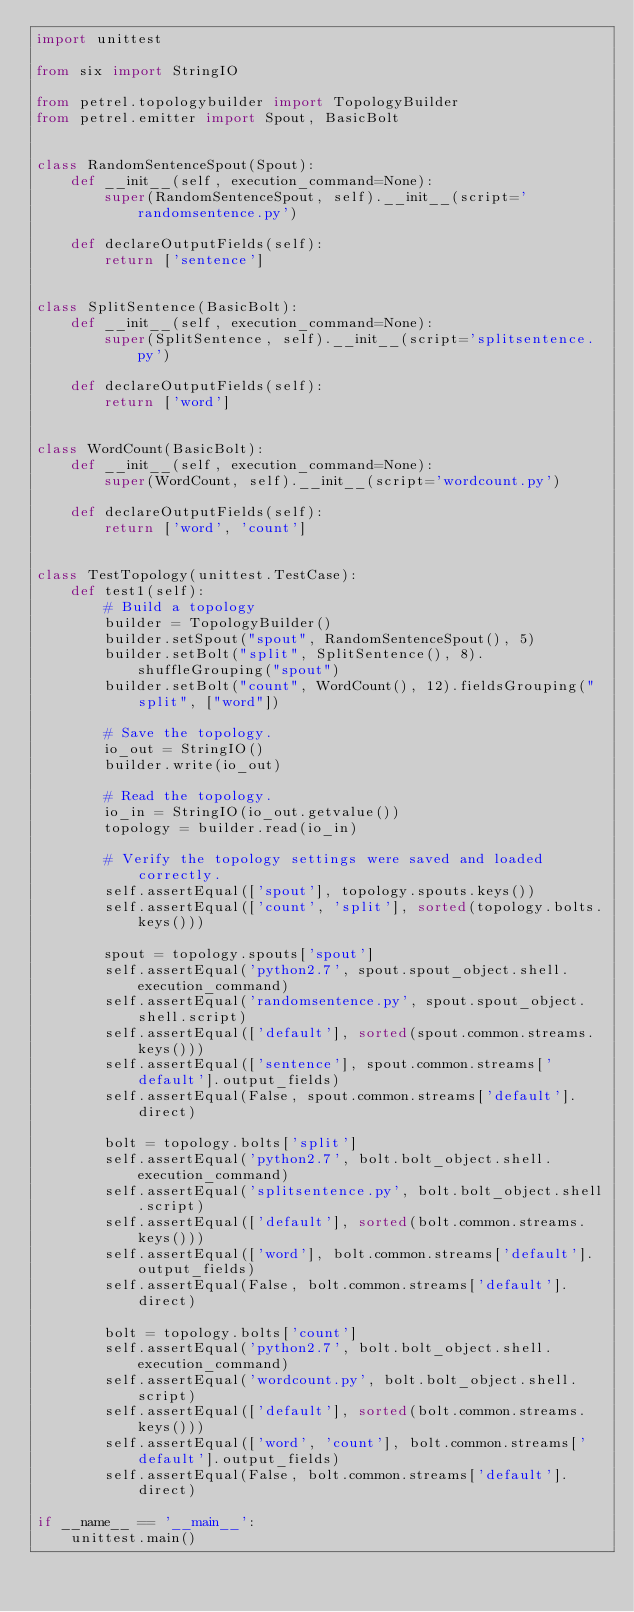<code> <loc_0><loc_0><loc_500><loc_500><_Python_>import unittest

from six import StringIO

from petrel.topologybuilder import TopologyBuilder
from petrel.emitter import Spout, BasicBolt


class RandomSentenceSpout(Spout):
    def __init__(self, execution_command=None):
        super(RandomSentenceSpout, self).__init__(script='randomsentence.py')

    def declareOutputFields(self):
        return ['sentence']


class SplitSentence(BasicBolt):
    def __init__(self, execution_command=None):
        super(SplitSentence, self).__init__(script='splitsentence.py')

    def declareOutputFields(self):
        return ['word']


class WordCount(BasicBolt):
    def __init__(self, execution_command=None):
        super(WordCount, self).__init__(script='wordcount.py')

    def declareOutputFields(self):
        return ['word', 'count']


class TestTopology(unittest.TestCase):
    def test1(self):
        # Build a topology
        builder = TopologyBuilder()
        builder.setSpout("spout", RandomSentenceSpout(), 5)
        builder.setBolt("split", SplitSentence(), 8).shuffleGrouping("spout")
        builder.setBolt("count", WordCount(), 12).fieldsGrouping("split", ["word"])

        # Save the topology.        
        io_out = StringIO()
        builder.write(io_out)
        
        # Read the topology.
        io_in = StringIO(io_out.getvalue())
        topology = builder.read(io_in)
        
        # Verify the topology settings were saved and loaded correctly.
        self.assertEqual(['spout'], topology.spouts.keys())
        self.assertEqual(['count', 'split'], sorted(topology.bolts.keys()))

        spout = topology.spouts['spout']
        self.assertEqual('python2.7', spout.spout_object.shell.execution_command)
        self.assertEqual('randomsentence.py', spout.spout_object.shell.script)
        self.assertEqual(['default'], sorted(spout.common.streams.keys()))
        self.assertEqual(['sentence'], spout.common.streams['default'].output_fields)
        self.assertEqual(False, spout.common.streams['default'].direct)

        bolt = topology.bolts['split']
        self.assertEqual('python2.7', bolt.bolt_object.shell.execution_command)
        self.assertEqual('splitsentence.py', bolt.bolt_object.shell.script)
        self.assertEqual(['default'], sorted(bolt.common.streams.keys()))
        self.assertEqual(['word'], bolt.common.streams['default'].output_fields)
        self.assertEqual(False, bolt.common.streams['default'].direct)

        bolt = topology.bolts['count']
        self.assertEqual('python2.7', bolt.bolt_object.shell.execution_command)
        self.assertEqual('wordcount.py', bolt.bolt_object.shell.script)
        self.assertEqual(['default'], sorted(bolt.common.streams.keys()))
        self.assertEqual(['word', 'count'], bolt.common.streams['default'].output_fields)
        self.assertEqual(False, bolt.common.streams['default'].direct)

if __name__ == '__main__':
    unittest.main()</code> 